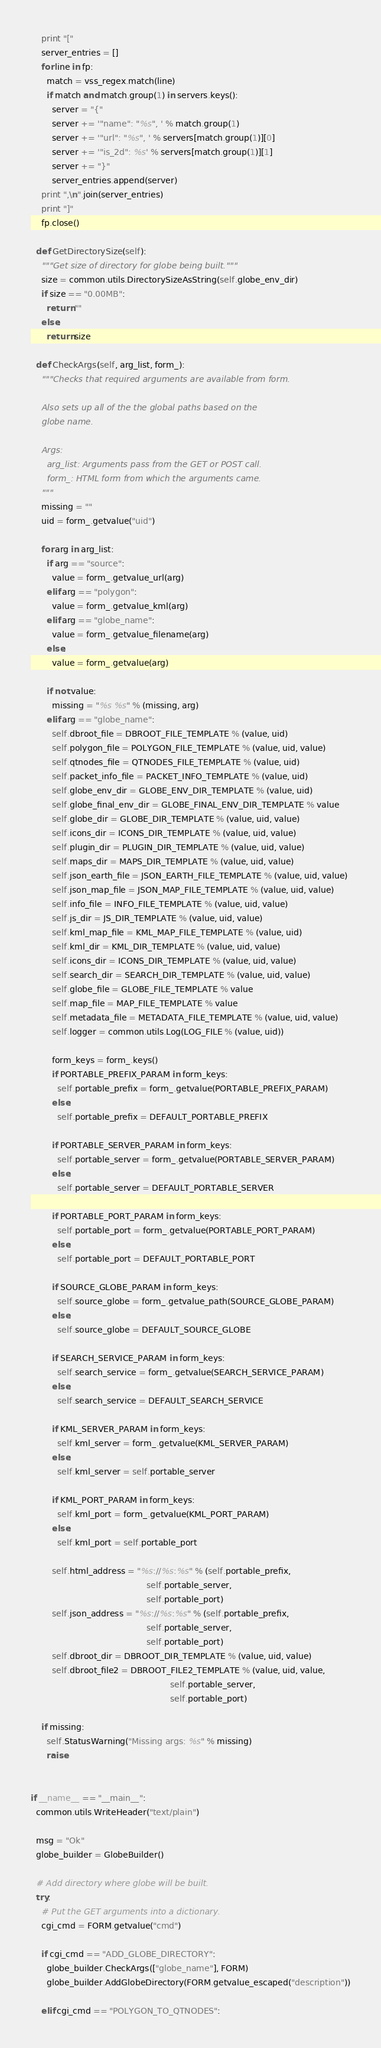<code> <loc_0><loc_0><loc_500><loc_500><_Python_>    print "["
    server_entries = []
    for line in fp:
      match = vss_regex.match(line)
      if match and match.group(1) in servers.keys():
        server = "{"
        server += '"name": "%s", ' % match.group(1)
        server += '"url": "%s", ' % servers[match.group(1)][0]
        server += '"is_2d": %s' % servers[match.group(1)][1]
        server += "}"
        server_entries.append(server)
    print ",\n".join(server_entries)
    print "]"
    fp.close()

  def GetDirectorySize(self):
    """Get size of directory for globe being built."""
    size = common.utils.DirectorySizeAsString(self.globe_env_dir)
    if size == "0.00MB":
      return ""
    else:
      return size

  def CheckArgs(self, arg_list, form_):
    """Checks that required arguments are available from form.

    Also sets up all of the the global paths based on the
    globe name.

    Args:
      arg_list: Arguments pass from the GET or POST call.
      form_: HTML form from which the arguments came.
    """
    missing = ""
    uid = form_.getvalue("uid")

    for arg in arg_list:
      if arg == "source":
        value = form_.getvalue_url(arg)
      elif arg == "polygon":
        value = form_.getvalue_kml(arg)
      elif arg == "globe_name":
        value = form_.getvalue_filename(arg)
      else:
        value = form_.getvalue(arg)

      if not value:
        missing = "%s %s" % (missing, arg)
      elif arg == "globe_name":
        self.dbroot_file = DBROOT_FILE_TEMPLATE % (value, uid)
        self.polygon_file = POLYGON_FILE_TEMPLATE % (value, uid, value)
        self.qtnodes_file = QTNODES_FILE_TEMPLATE % (value, uid)
        self.packet_info_file = PACKET_INFO_TEMPLATE % (value, uid)
        self.globe_env_dir = GLOBE_ENV_DIR_TEMPLATE % (value, uid)
        self.globe_final_env_dir = GLOBE_FINAL_ENV_DIR_TEMPLATE % value
        self.globe_dir = GLOBE_DIR_TEMPLATE % (value, uid, value)
        self.icons_dir = ICONS_DIR_TEMPLATE % (value, uid, value)
        self.plugin_dir = PLUGIN_DIR_TEMPLATE % (value, uid, value)
        self.maps_dir = MAPS_DIR_TEMPLATE % (value, uid, value)
        self.json_earth_file = JSON_EARTH_FILE_TEMPLATE % (value, uid, value)
        self.json_map_file = JSON_MAP_FILE_TEMPLATE % (value, uid, value)
        self.info_file = INFO_FILE_TEMPLATE % (value, uid, value)
        self.js_dir = JS_DIR_TEMPLATE % (value, uid, value)
        self.kml_map_file = KML_MAP_FILE_TEMPLATE % (value, uid)
        self.kml_dir = KML_DIR_TEMPLATE % (value, uid, value)
        self.icons_dir = ICONS_DIR_TEMPLATE % (value, uid, value)
        self.search_dir = SEARCH_DIR_TEMPLATE % (value, uid, value)
        self.globe_file = GLOBE_FILE_TEMPLATE % value
        self.map_file = MAP_FILE_TEMPLATE % value
        self.metadata_file = METADATA_FILE_TEMPLATE % (value, uid, value)
        self.logger = common.utils.Log(LOG_FILE % (value, uid))

        form_keys = form_.keys()
        if PORTABLE_PREFIX_PARAM in form_keys:
          self.portable_prefix = form_.getvalue(PORTABLE_PREFIX_PARAM)
        else:
          self.portable_prefix = DEFAULT_PORTABLE_PREFIX

        if PORTABLE_SERVER_PARAM in form_keys:
          self.portable_server = form_.getvalue(PORTABLE_SERVER_PARAM)
        else:
          self.portable_server = DEFAULT_PORTABLE_SERVER

        if PORTABLE_PORT_PARAM in form_keys:
          self.portable_port = form_.getvalue(PORTABLE_PORT_PARAM)
        else:
          self.portable_port = DEFAULT_PORTABLE_PORT

        if SOURCE_GLOBE_PARAM in form_keys:
          self.source_globe = form_.getvalue_path(SOURCE_GLOBE_PARAM)
        else:
          self.source_globe = DEFAULT_SOURCE_GLOBE

        if SEARCH_SERVICE_PARAM in form_keys:
          self.search_service = form_.getvalue(SEARCH_SERVICE_PARAM)
        else:
          self.search_service = DEFAULT_SEARCH_SERVICE

        if KML_SERVER_PARAM in form_keys:
          self.kml_server = form_.getvalue(KML_SERVER_PARAM)
        else:
          self.kml_server = self.portable_server

        if KML_PORT_PARAM in form_keys:
          self.kml_port = form_.getvalue(KML_PORT_PARAM)
        else:
          self.kml_port = self.portable_port

        self.html_address = "%s://%s:%s" % (self.portable_prefix,
                                            self.portable_server,
                                            self.portable_port)
        self.json_address = "%s://%s:%s" % (self.portable_prefix,
                                            self.portable_server,
                                            self.portable_port)
        self.dbroot_dir = DBROOT_DIR_TEMPLATE % (value, uid, value)
        self.dbroot_file2 = DBROOT_FILE2_TEMPLATE % (value, uid, value,
                                                     self.portable_server,
                                                     self.portable_port)

    if missing:
      self.StatusWarning("Missing args: %s" % missing)
      raise


if __name__ == "__main__":
  common.utils.WriteHeader("text/plain")

  msg = "Ok"
  globe_builder = GlobeBuilder()

  # Add directory where globe will be built.
  try:
    # Put the GET arguments into a dictionary.
    cgi_cmd = FORM.getvalue("cmd")

    if cgi_cmd == "ADD_GLOBE_DIRECTORY":
      globe_builder.CheckArgs(["globe_name"], FORM)
      globe_builder.AddGlobeDirectory(FORM.getvalue_escaped("description"))

    elif cgi_cmd == "POLYGON_TO_QTNODES":</code> 